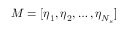<formula> <loc_0><loc_0><loc_500><loc_500>M = [ \eta _ { 1 } , \eta _ { 2 } , \dots , \eta _ { N _ { s } } ]</formula> 